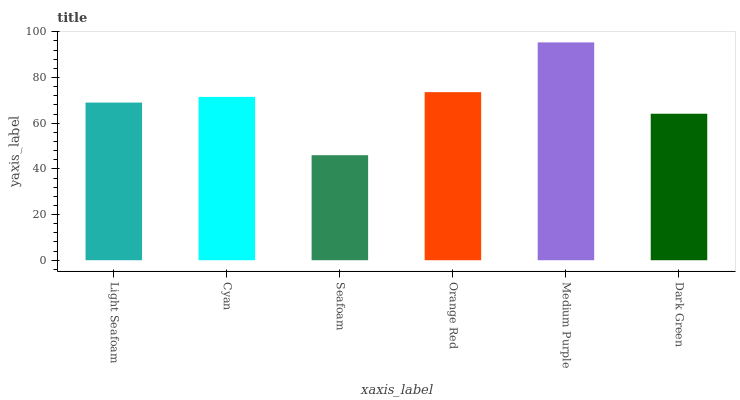Is Seafoam the minimum?
Answer yes or no. Yes. Is Medium Purple the maximum?
Answer yes or no. Yes. Is Cyan the minimum?
Answer yes or no. No. Is Cyan the maximum?
Answer yes or no. No. Is Cyan greater than Light Seafoam?
Answer yes or no. Yes. Is Light Seafoam less than Cyan?
Answer yes or no. Yes. Is Light Seafoam greater than Cyan?
Answer yes or no. No. Is Cyan less than Light Seafoam?
Answer yes or no. No. Is Cyan the high median?
Answer yes or no. Yes. Is Light Seafoam the low median?
Answer yes or no. Yes. Is Medium Purple the high median?
Answer yes or no. No. Is Medium Purple the low median?
Answer yes or no. No. 